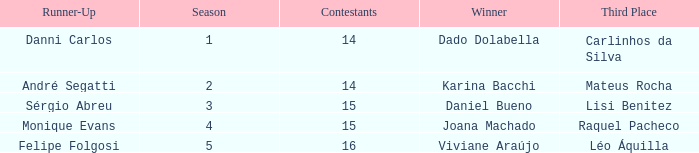In what season did Raquel Pacheco finish in third place? 4.0. 